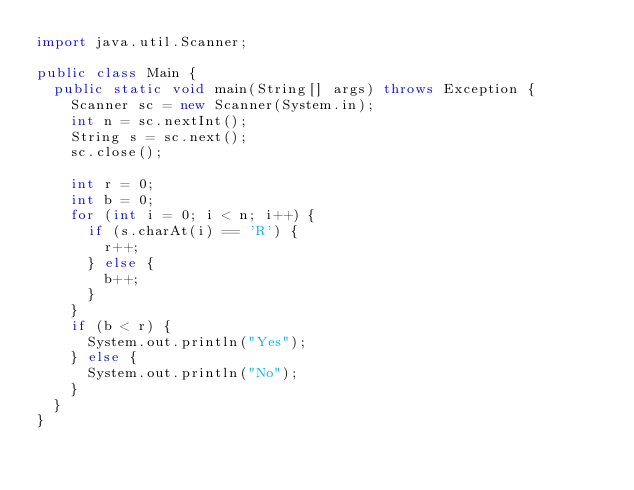<code> <loc_0><loc_0><loc_500><loc_500><_Java_>import java.util.Scanner;

public class Main {
	public static void main(String[] args) throws Exception {
		Scanner sc = new Scanner(System.in);
		int n = sc.nextInt();
		String s = sc.next();
		sc.close();

		int r = 0;
		int b = 0;
		for (int i = 0; i < n; i++) {
			if (s.charAt(i) == 'R') {
				r++;
			} else {
				b++;
			}
		}
		if (b < r) {
			System.out.println("Yes");
		} else {
			System.out.println("No");
		}
	}
}
</code> 